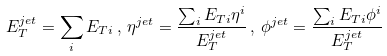<formula> <loc_0><loc_0><loc_500><loc_500>E _ { T } ^ { j e t } = \sum _ { i } E _ { T i } \, , \, \eta ^ { j e t } = \frac { \sum _ { i } E _ { T i } \eta ^ { i } } { E _ { T } ^ { j e t } } \, , \, \phi ^ { j e t } = \frac { \sum _ { i } E _ { T i } \phi ^ { i } } { E _ { T } ^ { j e t } }</formula> 